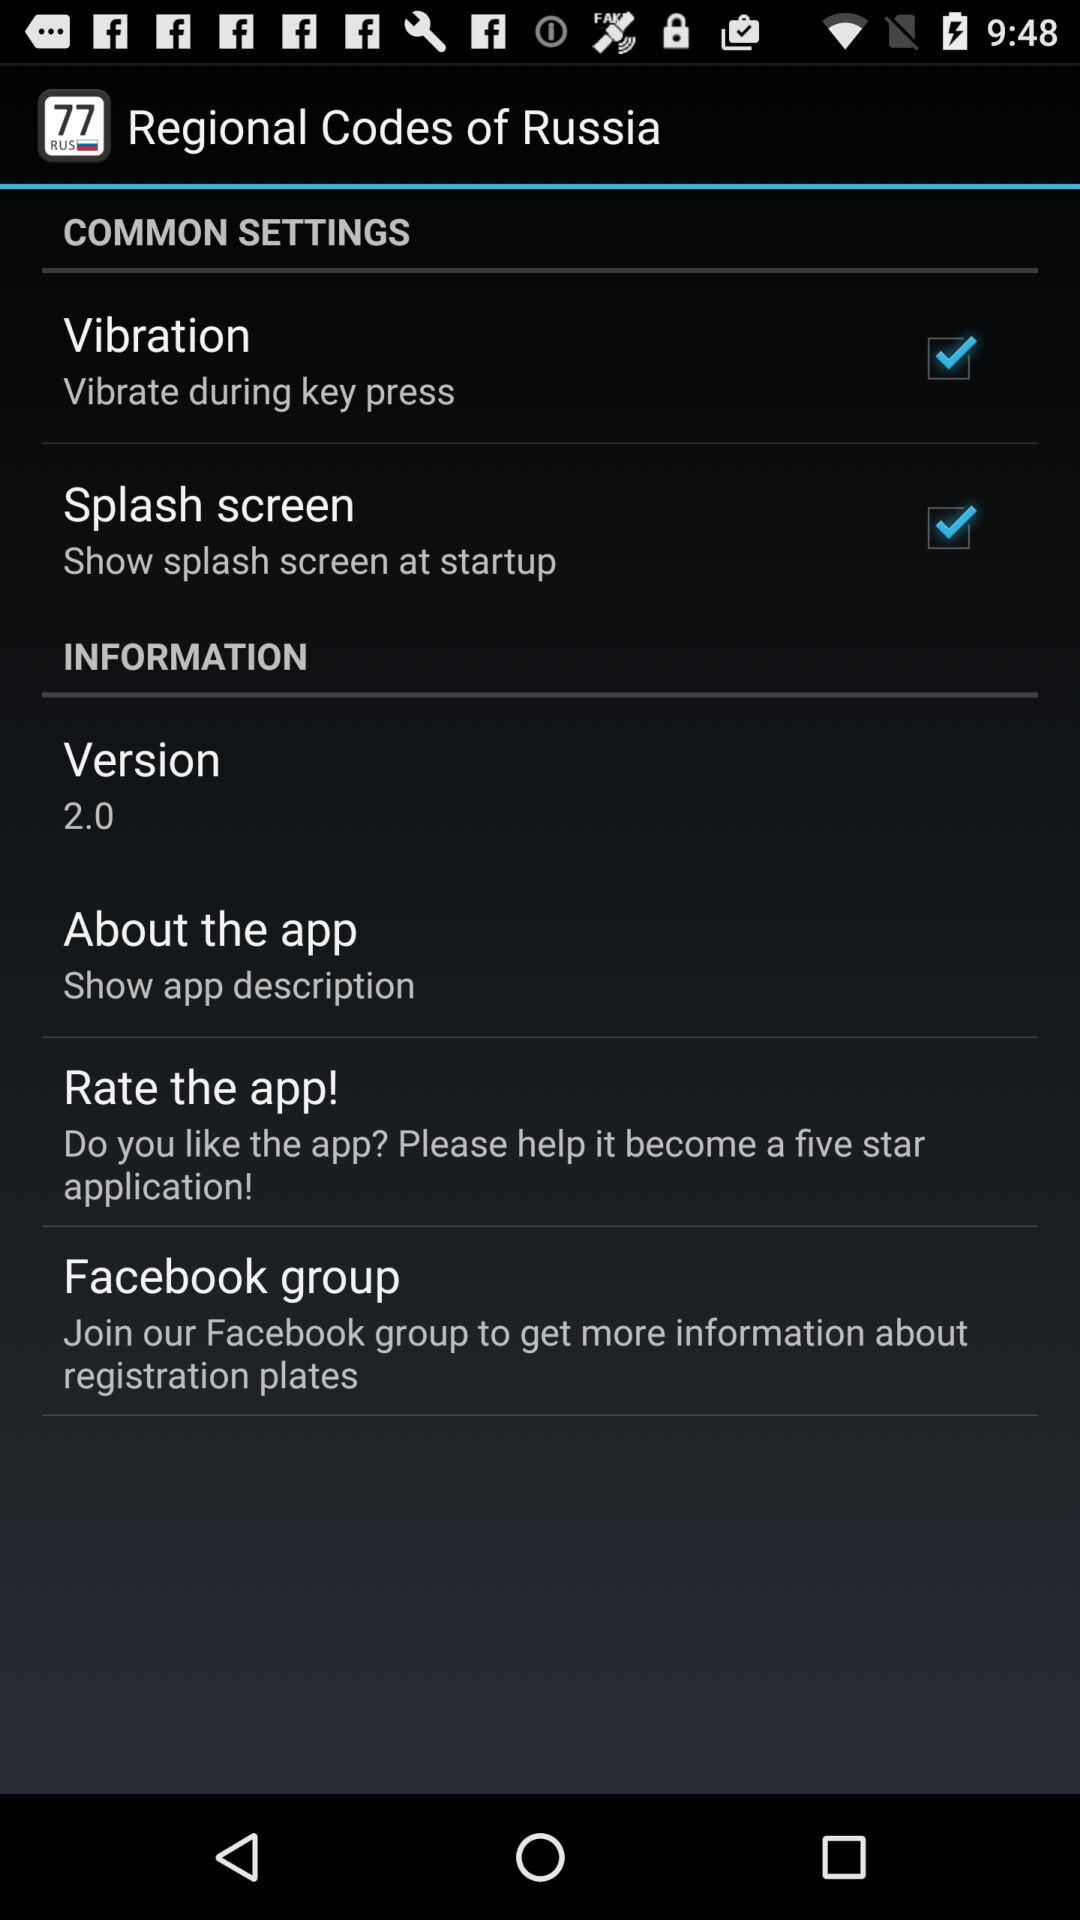What is the version? The version is 2.0. 